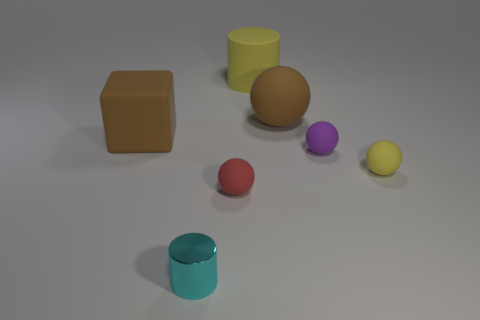Subtract 2 balls. How many balls are left? 2 Add 1 tiny yellow balls. How many objects exist? 8 Subtract all gray spheres. Subtract all yellow cubes. How many spheres are left? 4 Subtract all balls. How many objects are left? 3 Add 2 small cylinders. How many small cylinders are left? 3 Add 7 small matte objects. How many small matte objects exist? 10 Subtract 0 gray spheres. How many objects are left? 7 Subtract all yellow rubber balls. Subtract all cyan cylinders. How many objects are left? 5 